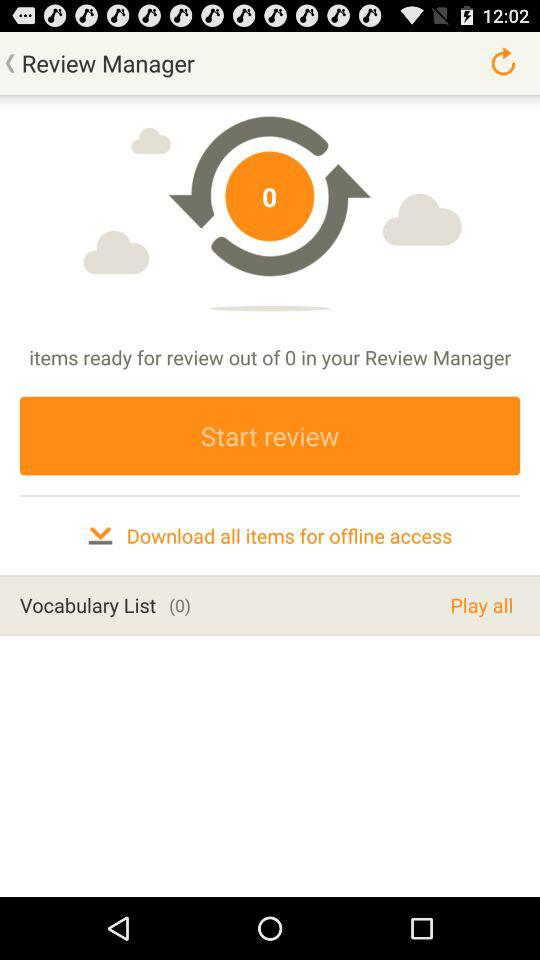How many items are in the review manager?
Answer the question using a single word or phrase. 0 